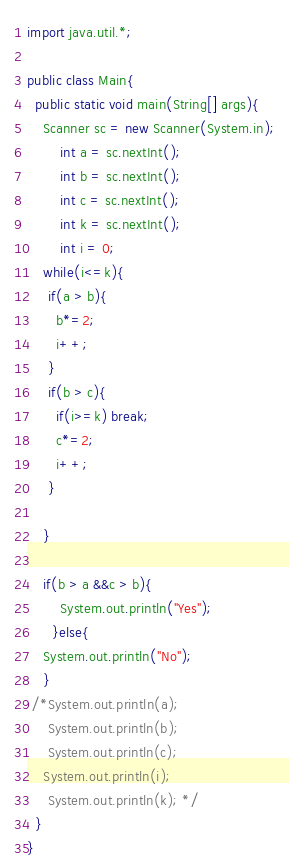Convert code to text. <code><loc_0><loc_0><loc_500><loc_500><_Java_>import java.util.*;
 
public class Main{
  public static void main(String[] args){
    Scanner sc = new Scanner(System.in);
        int a = sc.nextInt();
        int b = sc.nextInt();
    	int c = sc.nextInt();
    	int k = sc.nextInt();
    	int i = 0;
    while(i<=k){
     if(a > b){
       b*=2;
       i++;
     }
     if(b > c){
       if(i>=k) break;
       c*=2;
       i++;
     }
      
    }
   
    if(b > a &&c > b){
		System.out.println("Yes");
      }else{
    System.out.println("No");
    }
 /*System.out.println(a);
     System.out.println(b);
     System.out.println(c);
    System.out.println(i);
     System.out.println(k); */
  }
}</code> 